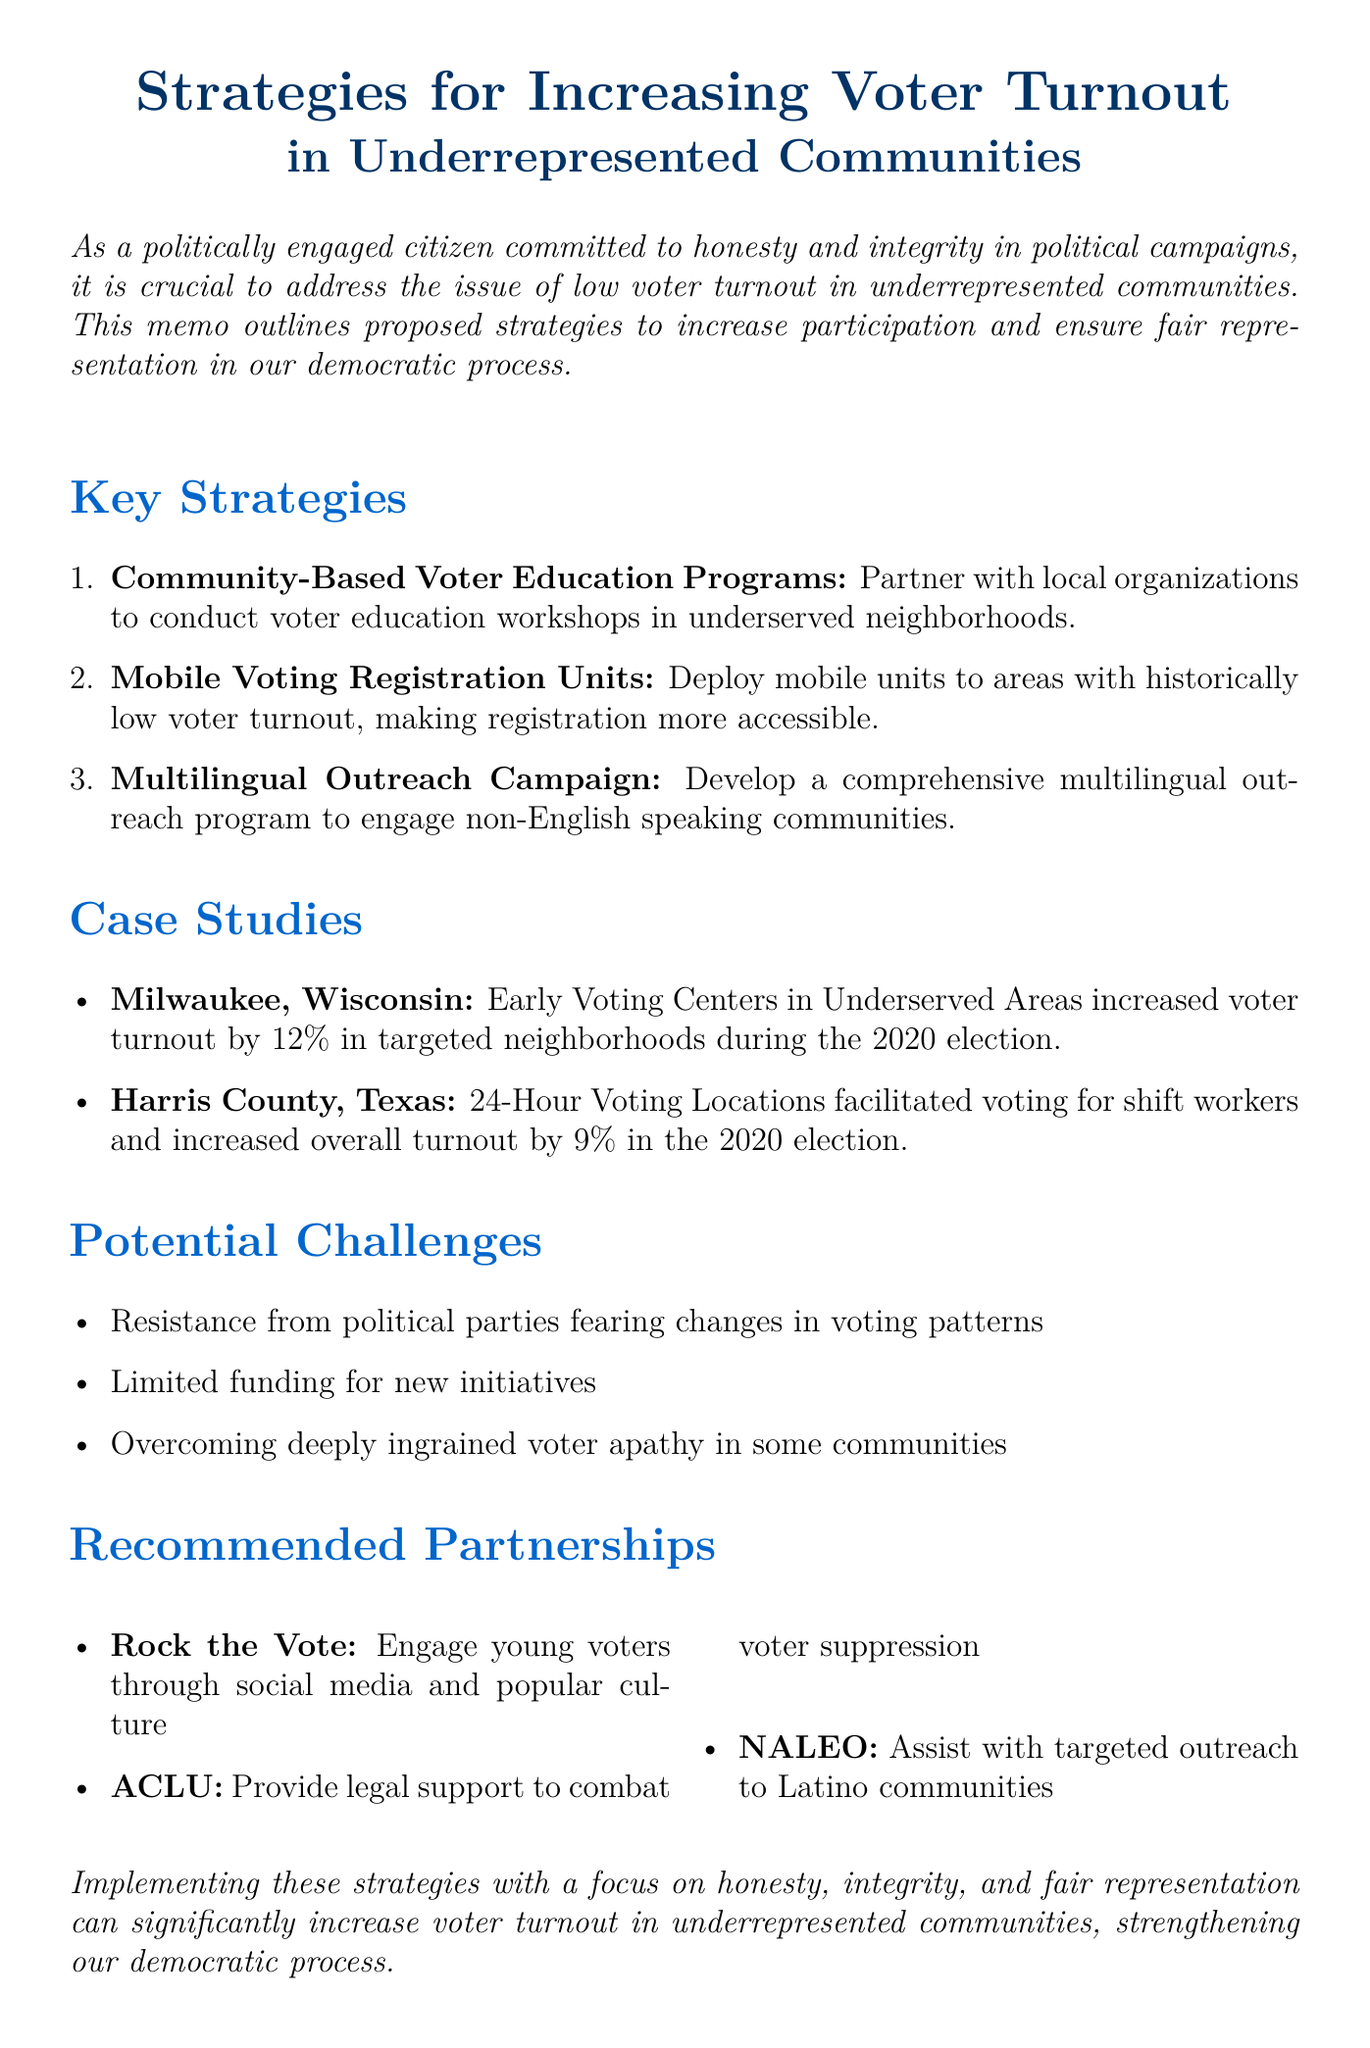what is the title of the memo? The title of the memo is found at the beginning of the document.
Answer: Strategies for Increasing Voter Turnout in Underrepresented Communities how many key strategies are proposed? The number of key strategies is indicated in the section listing them.
Answer: three which organization is suggested for engaging young voters? The document lists organizations and their roles, including one for engaging young voters.
Answer: Rock the Vote what was the voter turnout increase in Milwaukee during the 2020 election? The document provides a specific outcome related to voter turnout in Milwaukee.
Answer: 12% what potential challenge involves political parties? The document outlines potential challenges, including one relating to political parties' responses.
Answer: Resistance from political parties fearing changes in voting patterns which community organizations are suggested for partnership? The recommendations section details organizations for partnership efforts.
Answer: Rock the Vote, ACLU, NALEO 